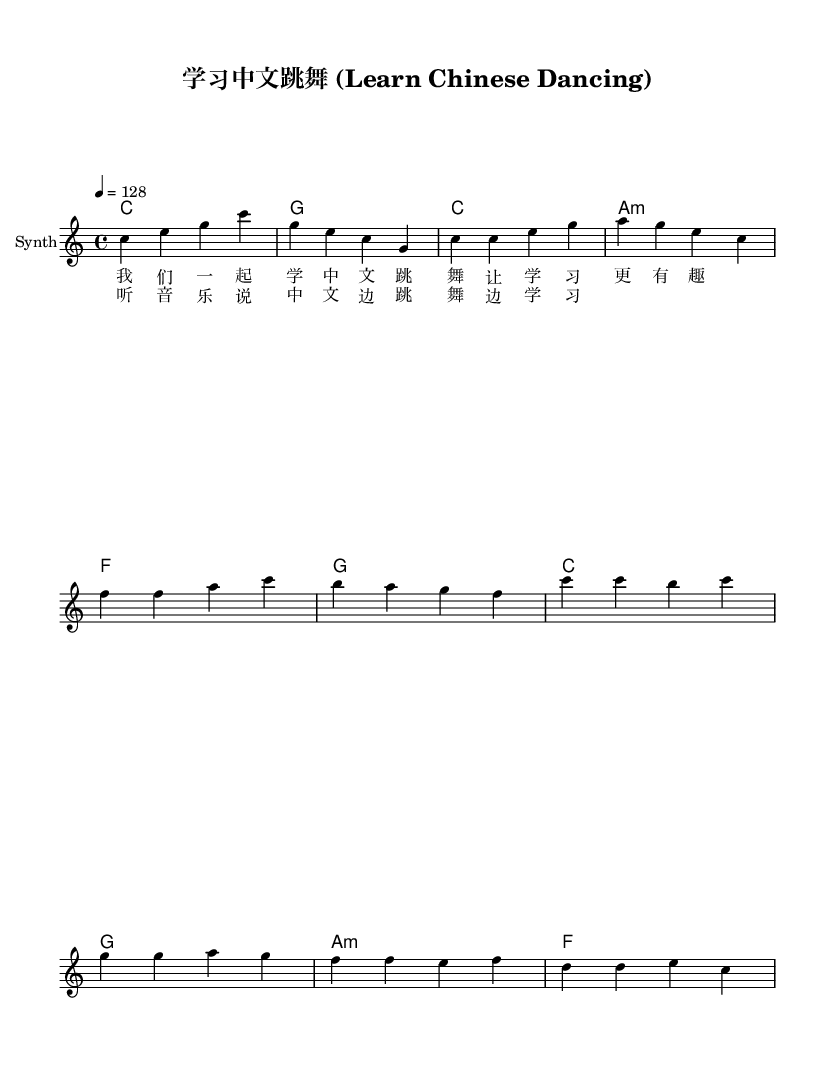What is the key signature of this music? The key signature is C major, which has no sharps or flats.
Answer: C major What is the time signature of this piece? The time signature is indicated as 4/4, meaning there are four beats per measure.
Answer: 4/4 What is the tempo marking for this music? The tempo marking shows that the music should be played at 128 beats per minute, as denoted by "4 = 128".
Answer: 128 How many measures are there in the verse? By counting the measures in the verses' grace notes and the chord progression, we find there are four measures in total.
Answer: Four What instruments are indicated in the score? The score indicates the use of a "Synth" instrument for the melody, as shown in the staff label.
Answer: Synth What theme do the lyrics convey? The lyrics promote learning Chinese through fun activities like dancing, as seen from the phrases provided.
Answer: Learning How is the chorus structured compared to the verse? The chorus has a repetitive structure and emphasizes the dual action of listening to music and dancing, contrasting with the more narrative style of the verse.
Answer: Repetitive 